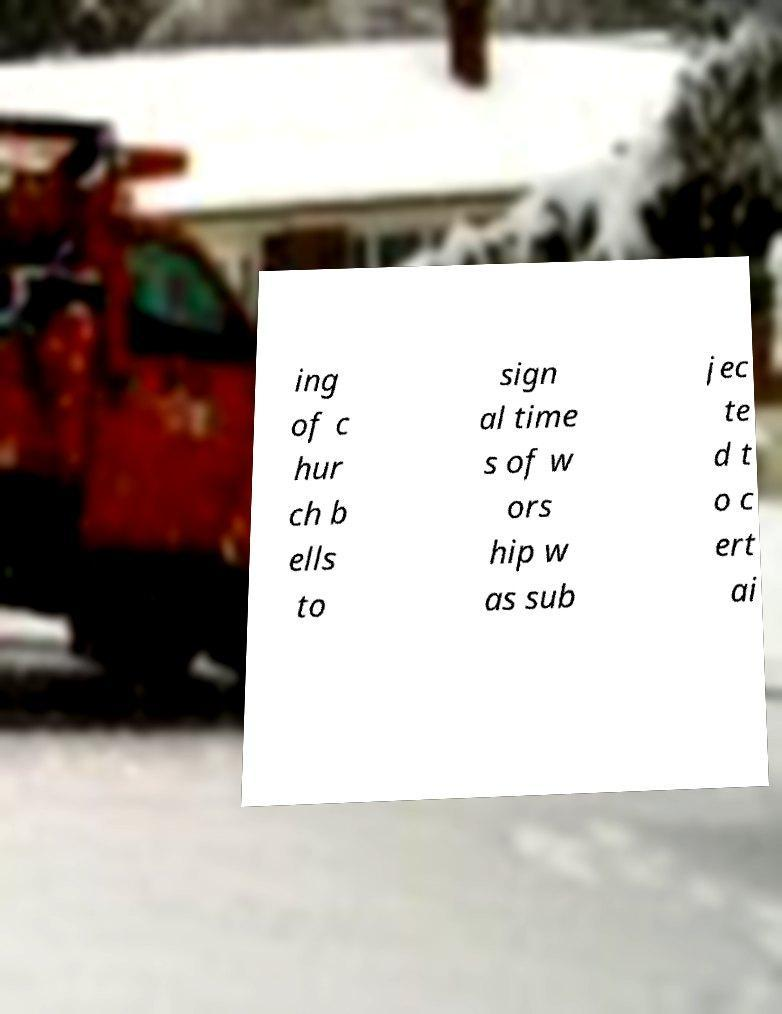Please read and relay the text visible in this image. What does it say? ing of c hur ch b ells to sign al time s of w ors hip w as sub jec te d t o c ert ai 